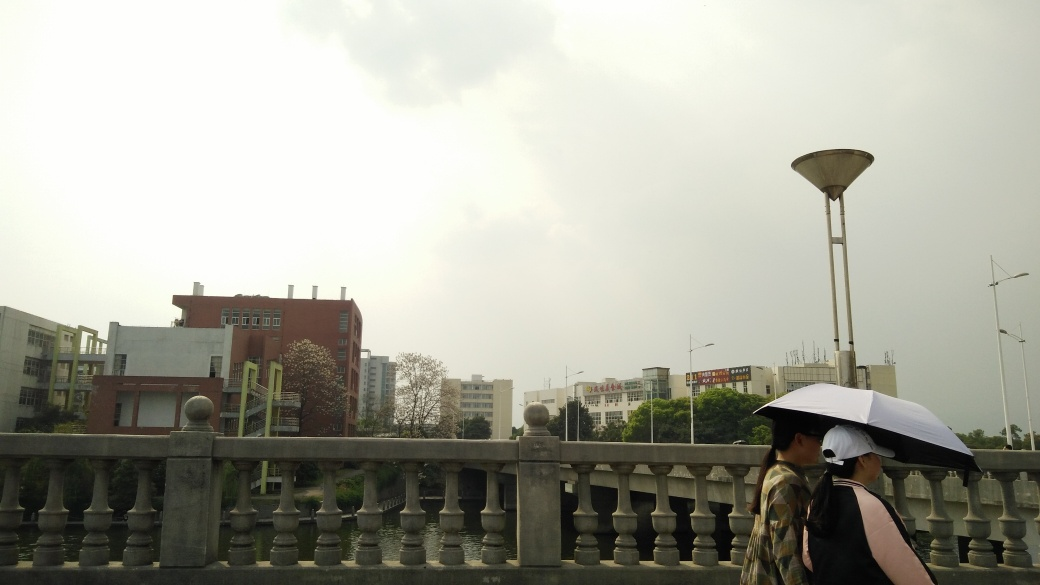Are there two people walking with umbrellas? Indeed, there are two individuals strolling side by side, one of whom is holding an umbrella to shield from the overcast sky. They appear prepared for potential rain, and the umbrella provides a practical and possibly a shared comfort. 